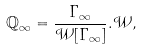Convert formula to latex. <formula><loc_0><loc_0><loc_500><loc_500>\mathbb { Q } _ { \infty } = \frac { \Gamma _ { \infty } } { \mathcal { W } [ \Gamma _ { \infty } ] } . \mathcal { W } ,</formula> 